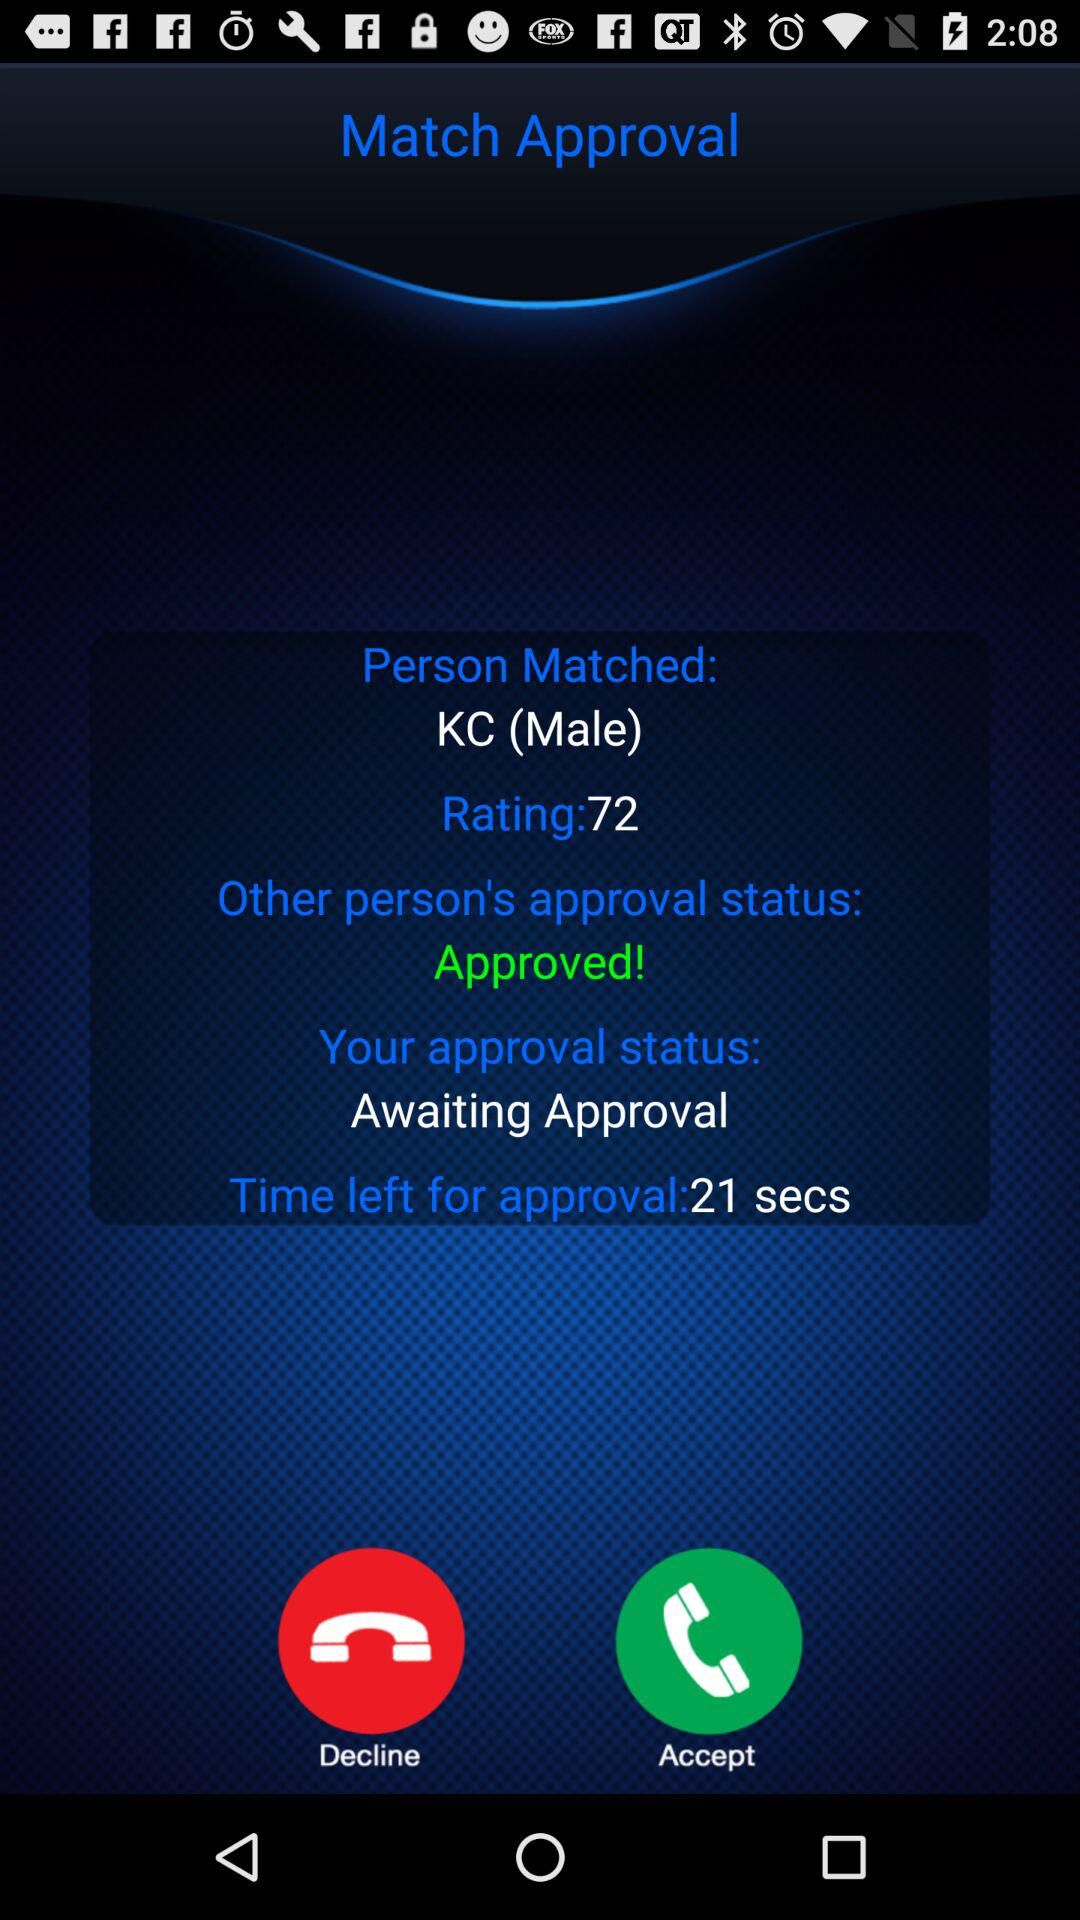How much time is left for approval? The time left for approval is 21 seconds. 